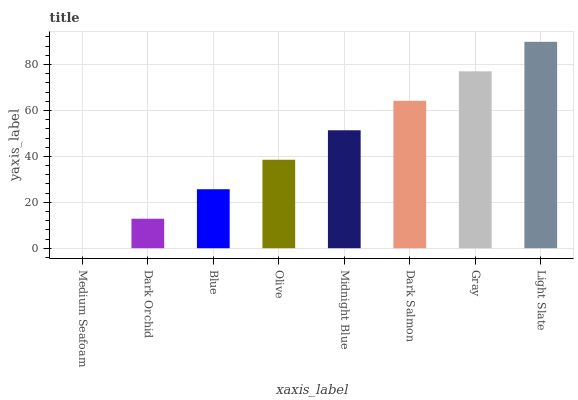Is Medium Seafoam the minimum?
Answer yes or no. Yes. Is Light Slate the maximum?
Answer yes or no. Yes. Is Dark Orchid the minimum?
Answer yes or no. No. Is Dark Orchid the maximum?
Answer yes or no. No. Is Dark Orchid greater than Medium Seafoam?
Answer yes or no. Yes. Is Medium Seafoam less than Dark Orchid?
Answer yes or no. Yes. Is Medium Seafoam greater than Dark Orchid?
Answer yes or no. No. Is Dark Orchid less than Medium Seafoam?
Answer yes or no. No. Is Midnight Blue the high median?
Answer yes or no. Yes. Is Olive the low median?
Answer yes or no. Yes. Is Light Slate the high median?
Answer yes or no. No. Is Light Slate the low median?
Answer yes or no. No. 